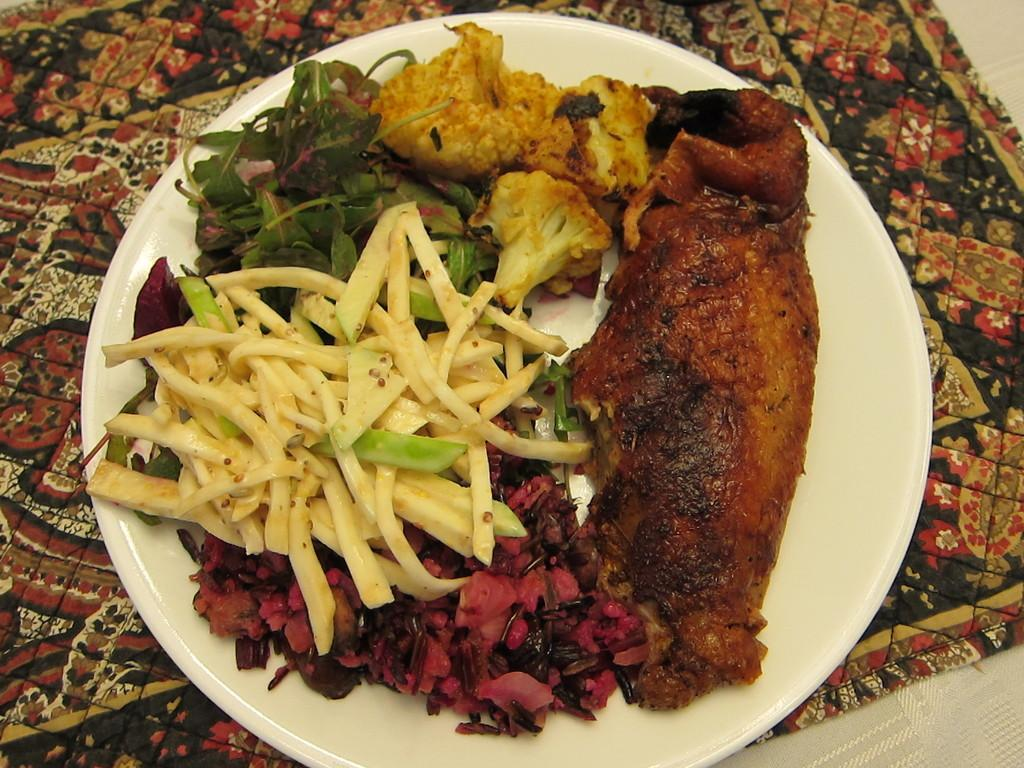What is on the plate that is visible in the image? There are food items on a plate in the image. Where is the plate located in the image? The plate is placed on a table mat or cloth. How many men are present in the image? There is no information about men in the image, as it only shows a plate with food items on a table mat or cloth. What is the taste of the food on the plate? The taste of the food cannot be determined from the image, as taste is a sensory experience and not visible. 